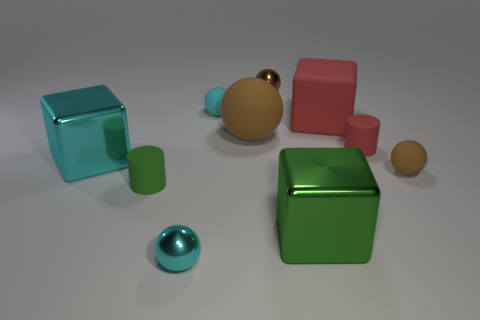Subtract all green cylinders. How many brown spheres are left? 3 Subtract all small cyan matte balls. How many balls are left? 4 Subtract all red spheres. Subtract all green cylinders. How many spheres are left? 5 Subtract all blocks. How many objects are left? 7 Subtract 0 yellow cylinders. How many objects are left? 10 Subtract all cyan rubber spheres. Subtract all red cubes. How many objects are left? 8 Add 8 tiny brown metal things. How many tiny brown metal things are left? 9 Add 1 red metallic spheres. How many red metallic spheres exist? 1 